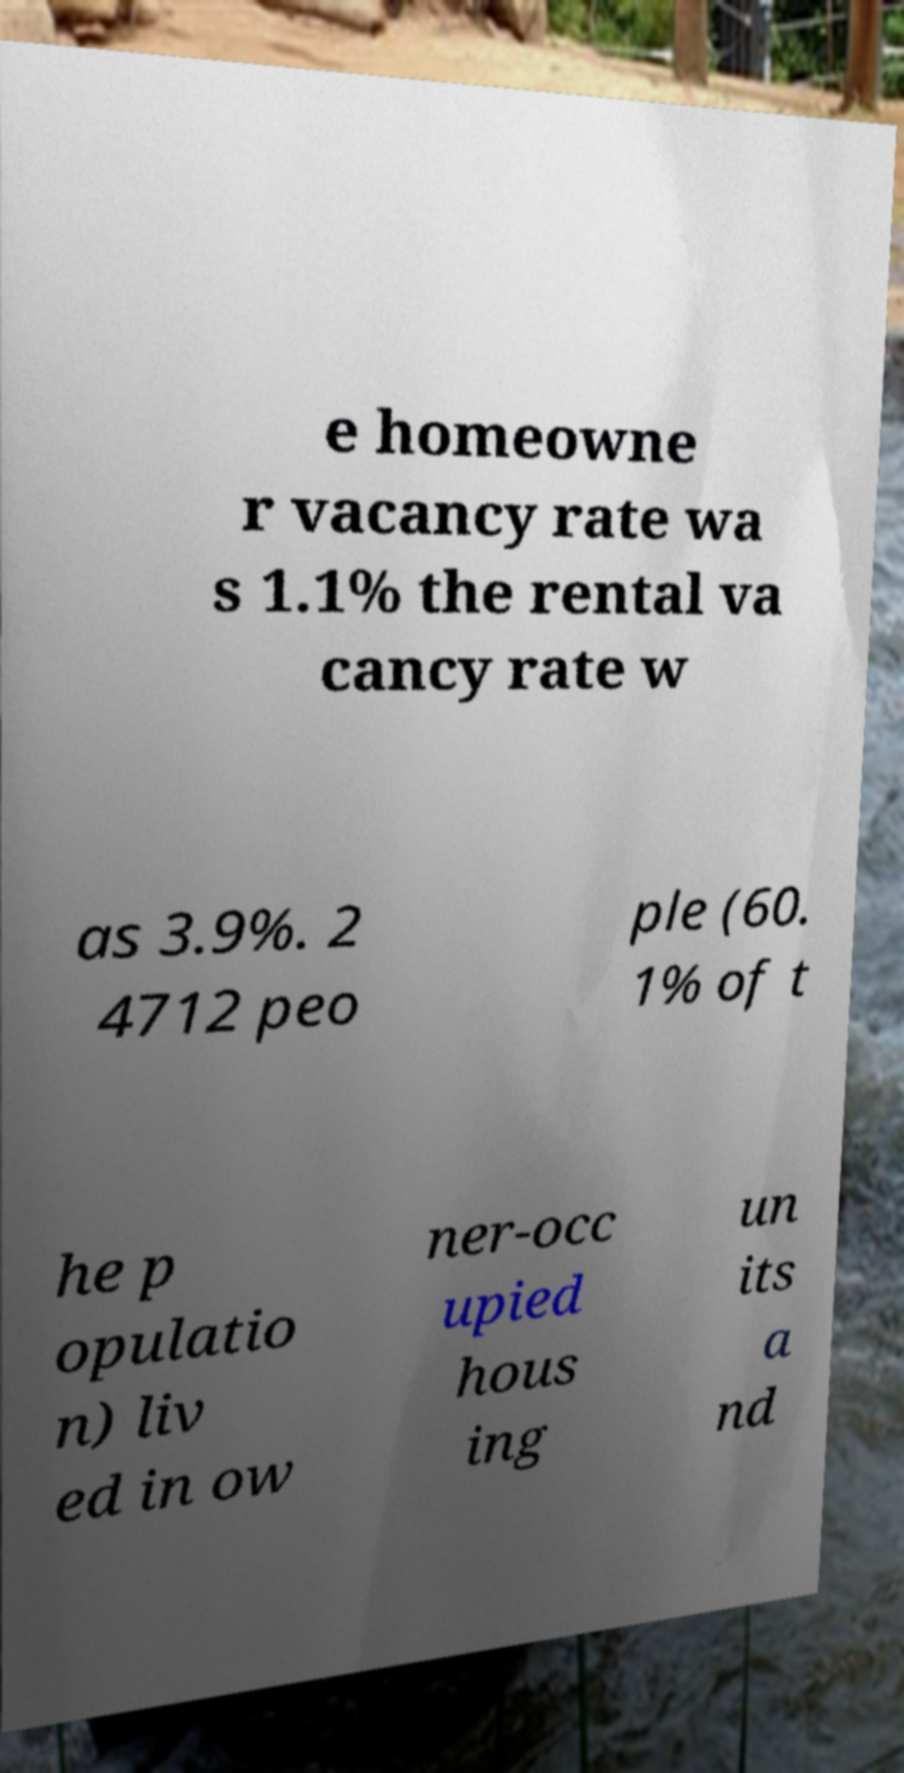Could you extract and type out the text from this image? e homeowne r vacancy rate wa s 1.1% the rental va cancy rate w as 3.9%. 2 4712 peo ple (60. 1% of t he p opulatio n) liv ed in ow ner-occ upied hous ing un its a nd 